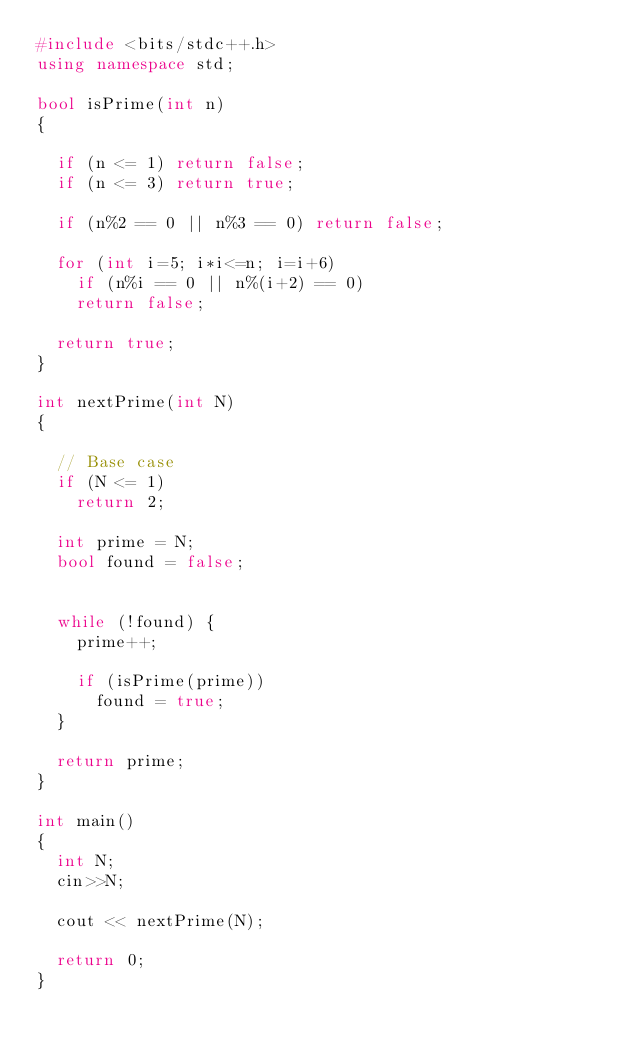<code> <loc_0><loc_0><loc_500><loc_500><_C++_>#include <bits/stdc++.h> 
using namespace std; 

bool isPrime(int n) 
{ 

	if (n <= 1) return false; 
	if (n <= 3) return true; 

	if (n%2 == 0 || n%3 == 0) return false; 
	
	for (int i=5; i*i<=n; i=i+6) 
		if (n%i == 0 || n%(i+2) == 0) 
		return false; 
	
	return true; 
} 

int nextPrime(int N) 
{ 

	// Base case 
	if (N <= 1) 
		return 2; 

	int prime = N; 
	bool found = false; 


	while (!found) { 
		prime++; 

		if (isPrime(prime)) 
			found = true; 
	} 

	return prime; 
} 

int main() 
{ 
	int N; 
  cin>>N;

	cout << nextPrime(N); 

	return 0; 
} 
</code> 